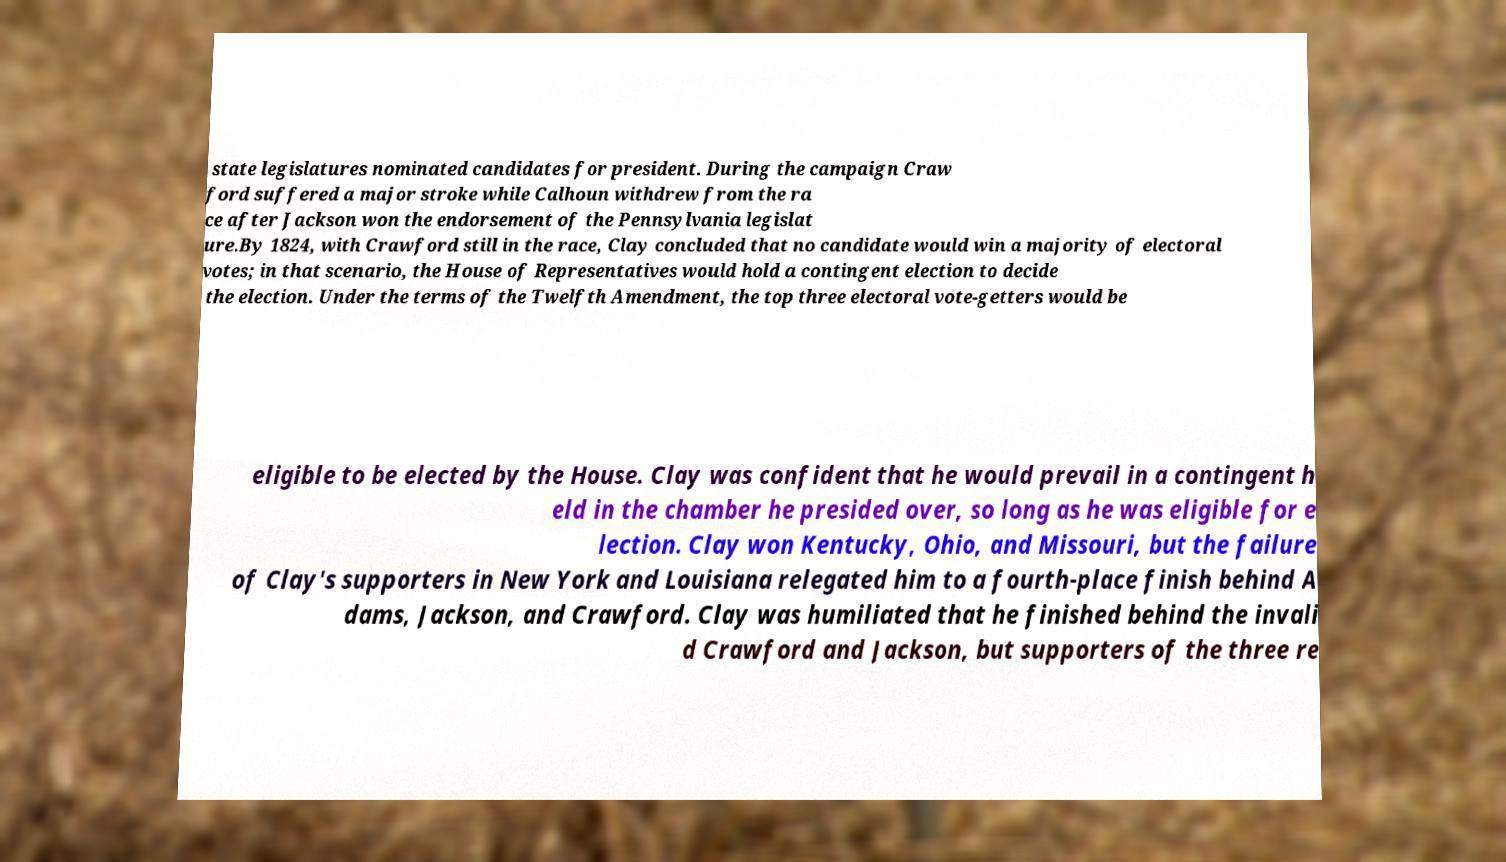Please identify and transcribe the text found in this image. state legislatures nominated candidates for president. During the campaign Craw ford suffered a major stroke while Calhoun withdrew from the ra ce after Jackson won the endorsement of the Pennsylvania legislat ure.By 1824, with Crawford still in the race, Clay concluded that no candidate would win a majority of electoral votes; in that scenario, the House of Representatives would hold a contingent election to decide the election. Under the terms of the Twelfth Amendment, the top three electoral vote-getters would be eligible to be elected by the House. Clay was confident that he would prevail in a contingent h eld in the chamber he presided over, so long as he was eligible for e lection. Clay won Kentucky, Ohio, and Missouri, but the failure of Clay's supporters in New York and Louisiana relegated him to a fourth-place finish behind A dams, Jackson, and Crawford. Clay was humiliated that he finished behind the invali d Crawford and Jackson, but supporters of the three re 